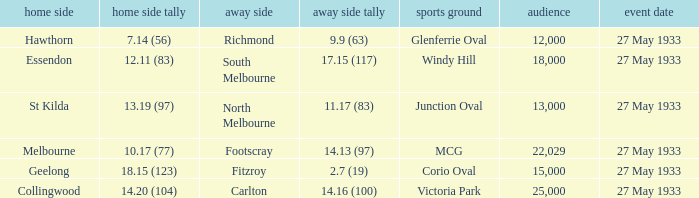In the match where the away team scored 2.7 (19), how many peopel were in the crowd? 15000.0. 